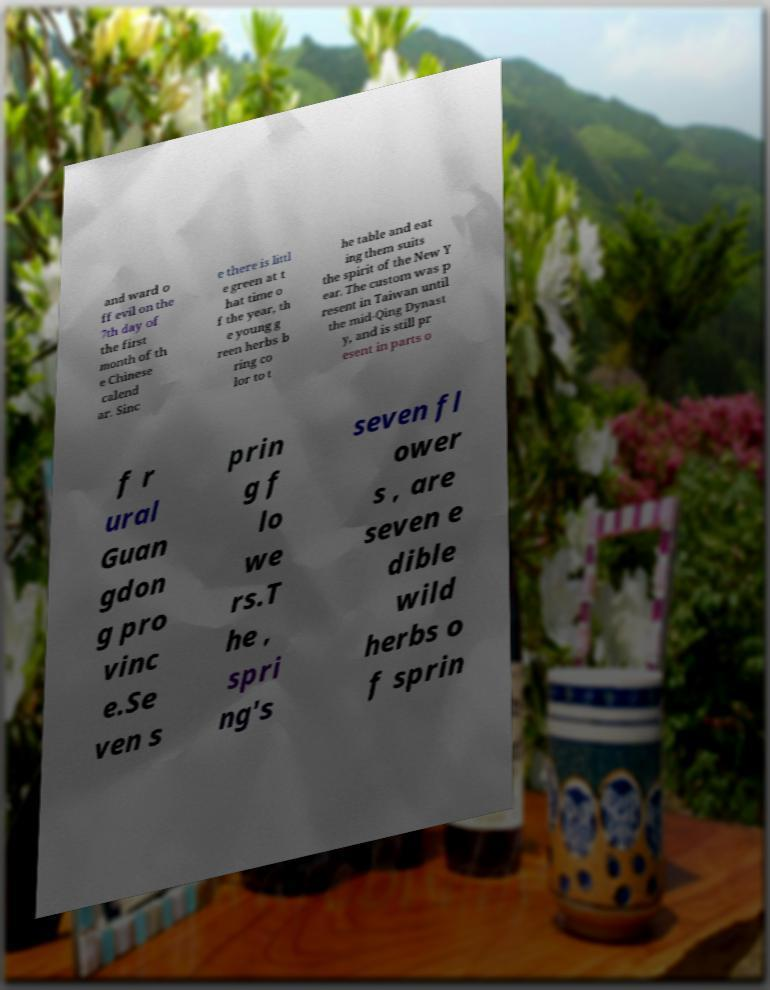For documentation purposes, I need the text within this image transcribed. Could you provide that? and ward o ff evil on the 7th day of the first month of th e Chinese calend ar. Sinc e there is littl e green at t hat time o f the year, th e young g reen herbs b ring co lor to t he table and eat ing them suits the spirit of the New Y ear. The custom was p resent in Taiwan until the mid-Qing Dynast y, and is still pr esent in parts o f r ural Guan gdon g pro vinc e.Se ven s prin g f lo we rs.T he , spri ng's seven fl ower s , are seven e dible wild herbs o f sprin 